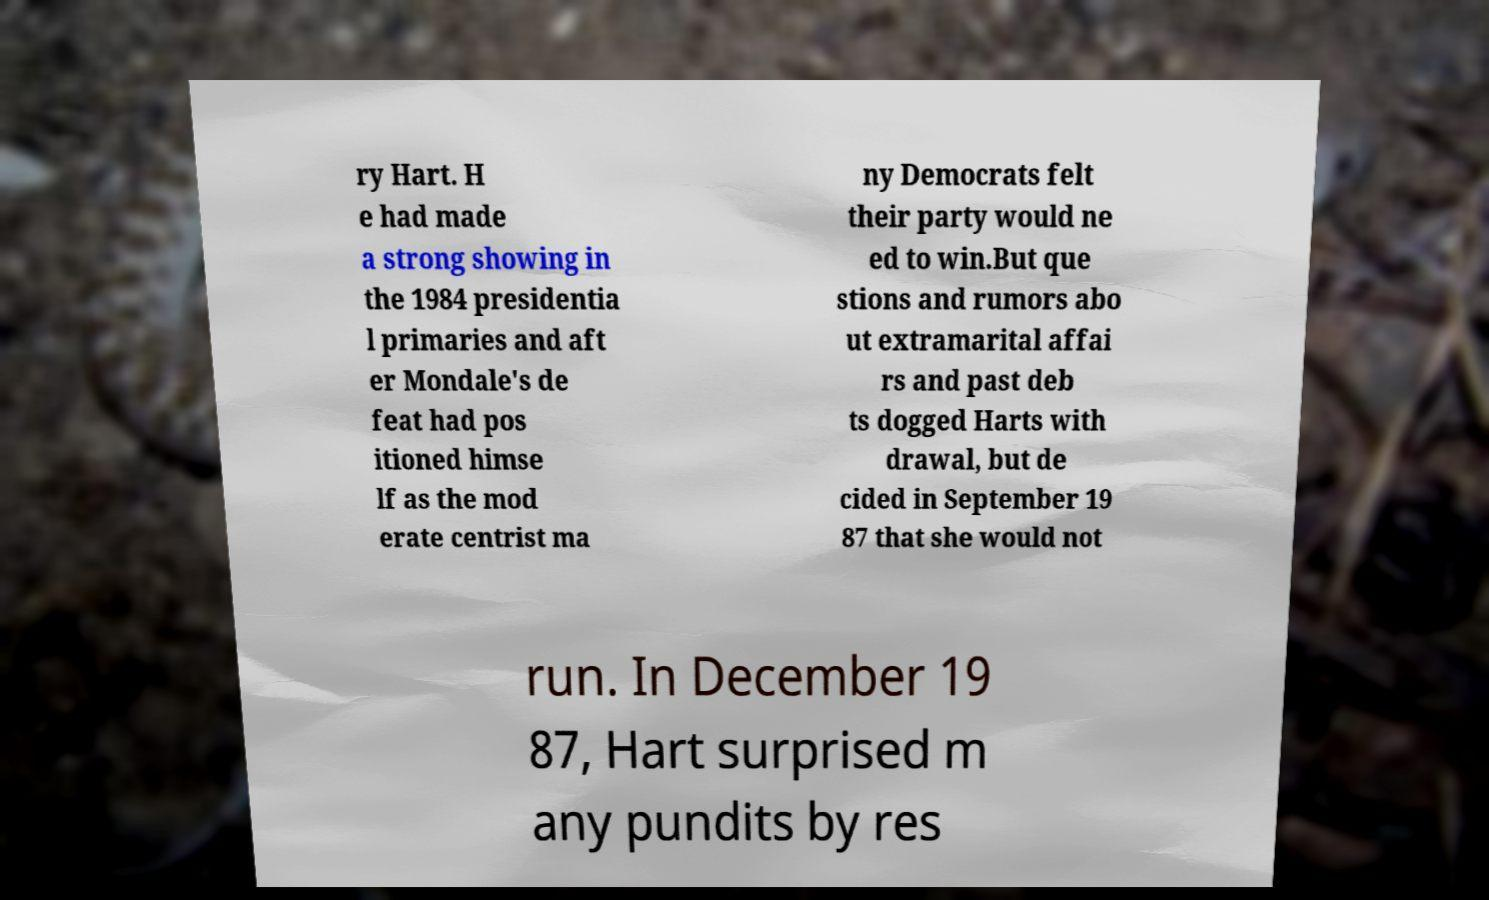Can you accurately transcribe the text from the provided image for me? ry Hart. H e had made a strong showing in the 1984 presidentia l primaries and aft er Mondale's de feat had pos itioned himse lf as the mod erate centrist ma ny Democrats felt their party would ne ed to win.But que stions and rumors abo ut extramarital affai rs and past deb ts dogged Harts with drawal, but de cided in September 19 87 that she would not run. In December 19 87, Hart surprised m any pundits by res 